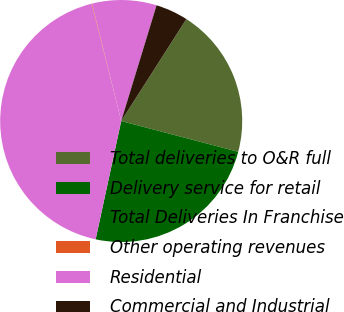<chart> <loc_0><loc_0><loc_500><loc_500><pie_chart><fcel>Total deliveries to O&R full<fcel>Delivery service for retail<fcel>Total Deliveries In Franchise<fcel>Other operating revenues<fcel>Residential<fcel>Commercial and Industrial<nl><fcel>20.04%<fcel>24.3%<fcel>42.68%<fcel>0.07%<fcel>8.59%<fcel>4.33%<nl></chart> 